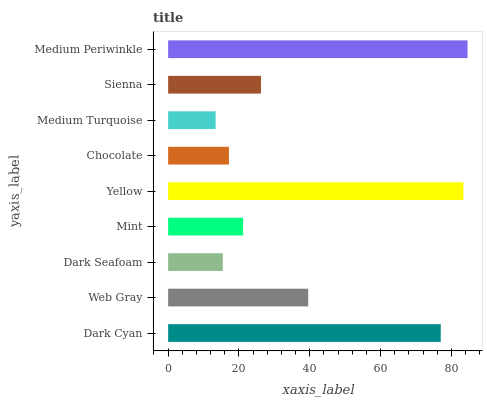Is Medium Turquoise the minimum?
Answer yes or no. Yes. Is Medium Periwinkle the maximum?
Answer yes or no. Yes. Is Web Gray the minimum?
Answer yes or no. No. Is Web Gray the maximum?
Answer yes or no. No. Is Dark Cyan greater than Web Gray?
Answer yes or no. Yes. Is Web Gray less than Dark Cyan?
Answer yes or no. Yes. Is Web Gray greater than Dark Cyan?
Answer yes or no. No. Is Dark Cyan less than Web Gray?
Answer yes or no. No. Is Sienna the high median?
Answer yes or no. Yes. Is Sienna the low median?
Answer yes or no. Yes. Is Mint the high median?
Answer yes or no. No. Is Yellow the low median?
Answer yes or no. No. 